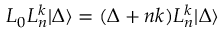<formula> <loc_0><loc_0><loc_500><loc_500>L _ { 0 } L _ { n } ^ { k } | \Delta \rangle = ( \Delta + n k ) L _ { n } ^ { k } | \Delta \rangle</formula> 